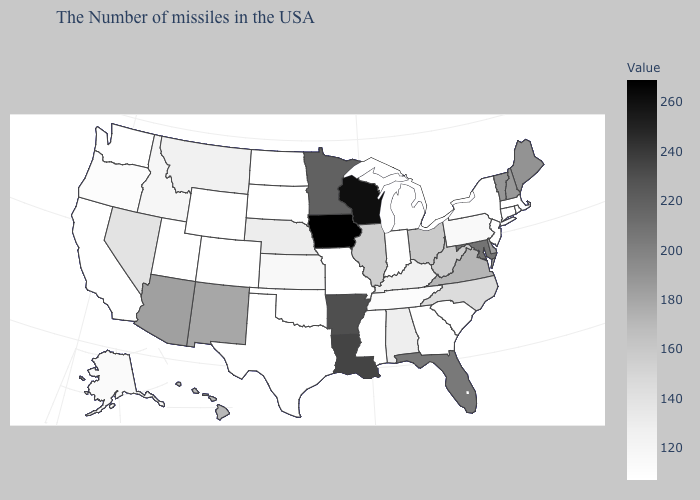Which states hav the highest value in the West?
Answer briefly. Arizona. Does Connecticut have the highest value in the Northeast?
Keep it brief. No. 